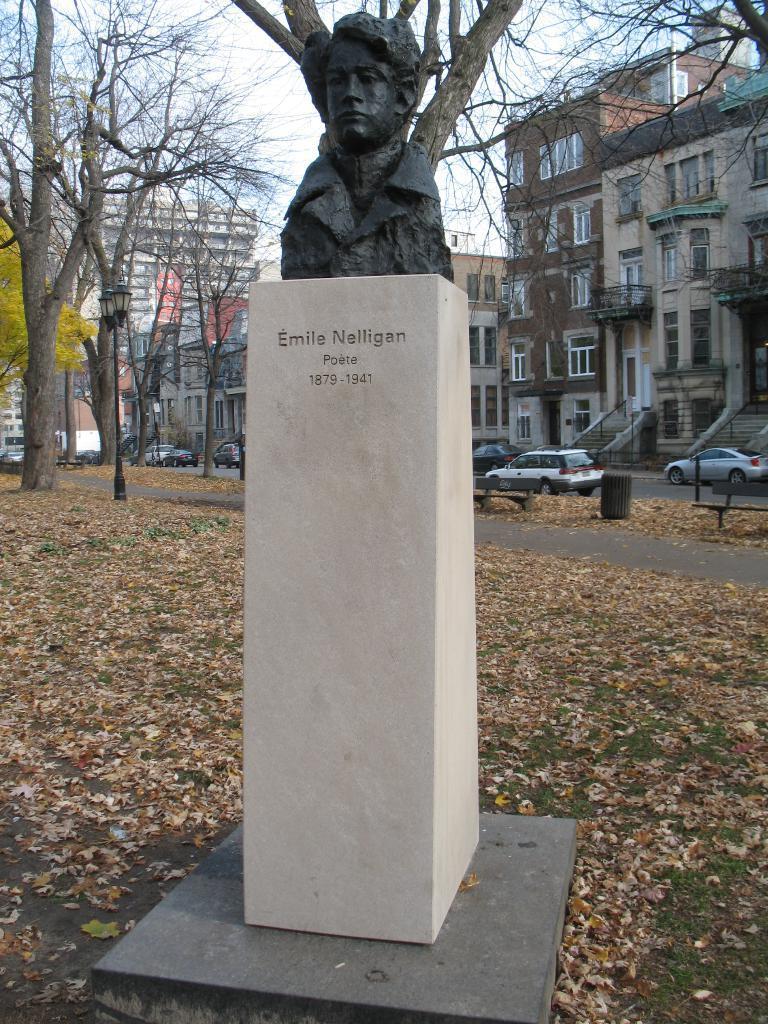How would you summarize this image in a sentence or two? In this image I can see few buildings, windows, trees, stairs, fencing, statue, few vehicles and few brown color leaves on the road. I can see the sky. 